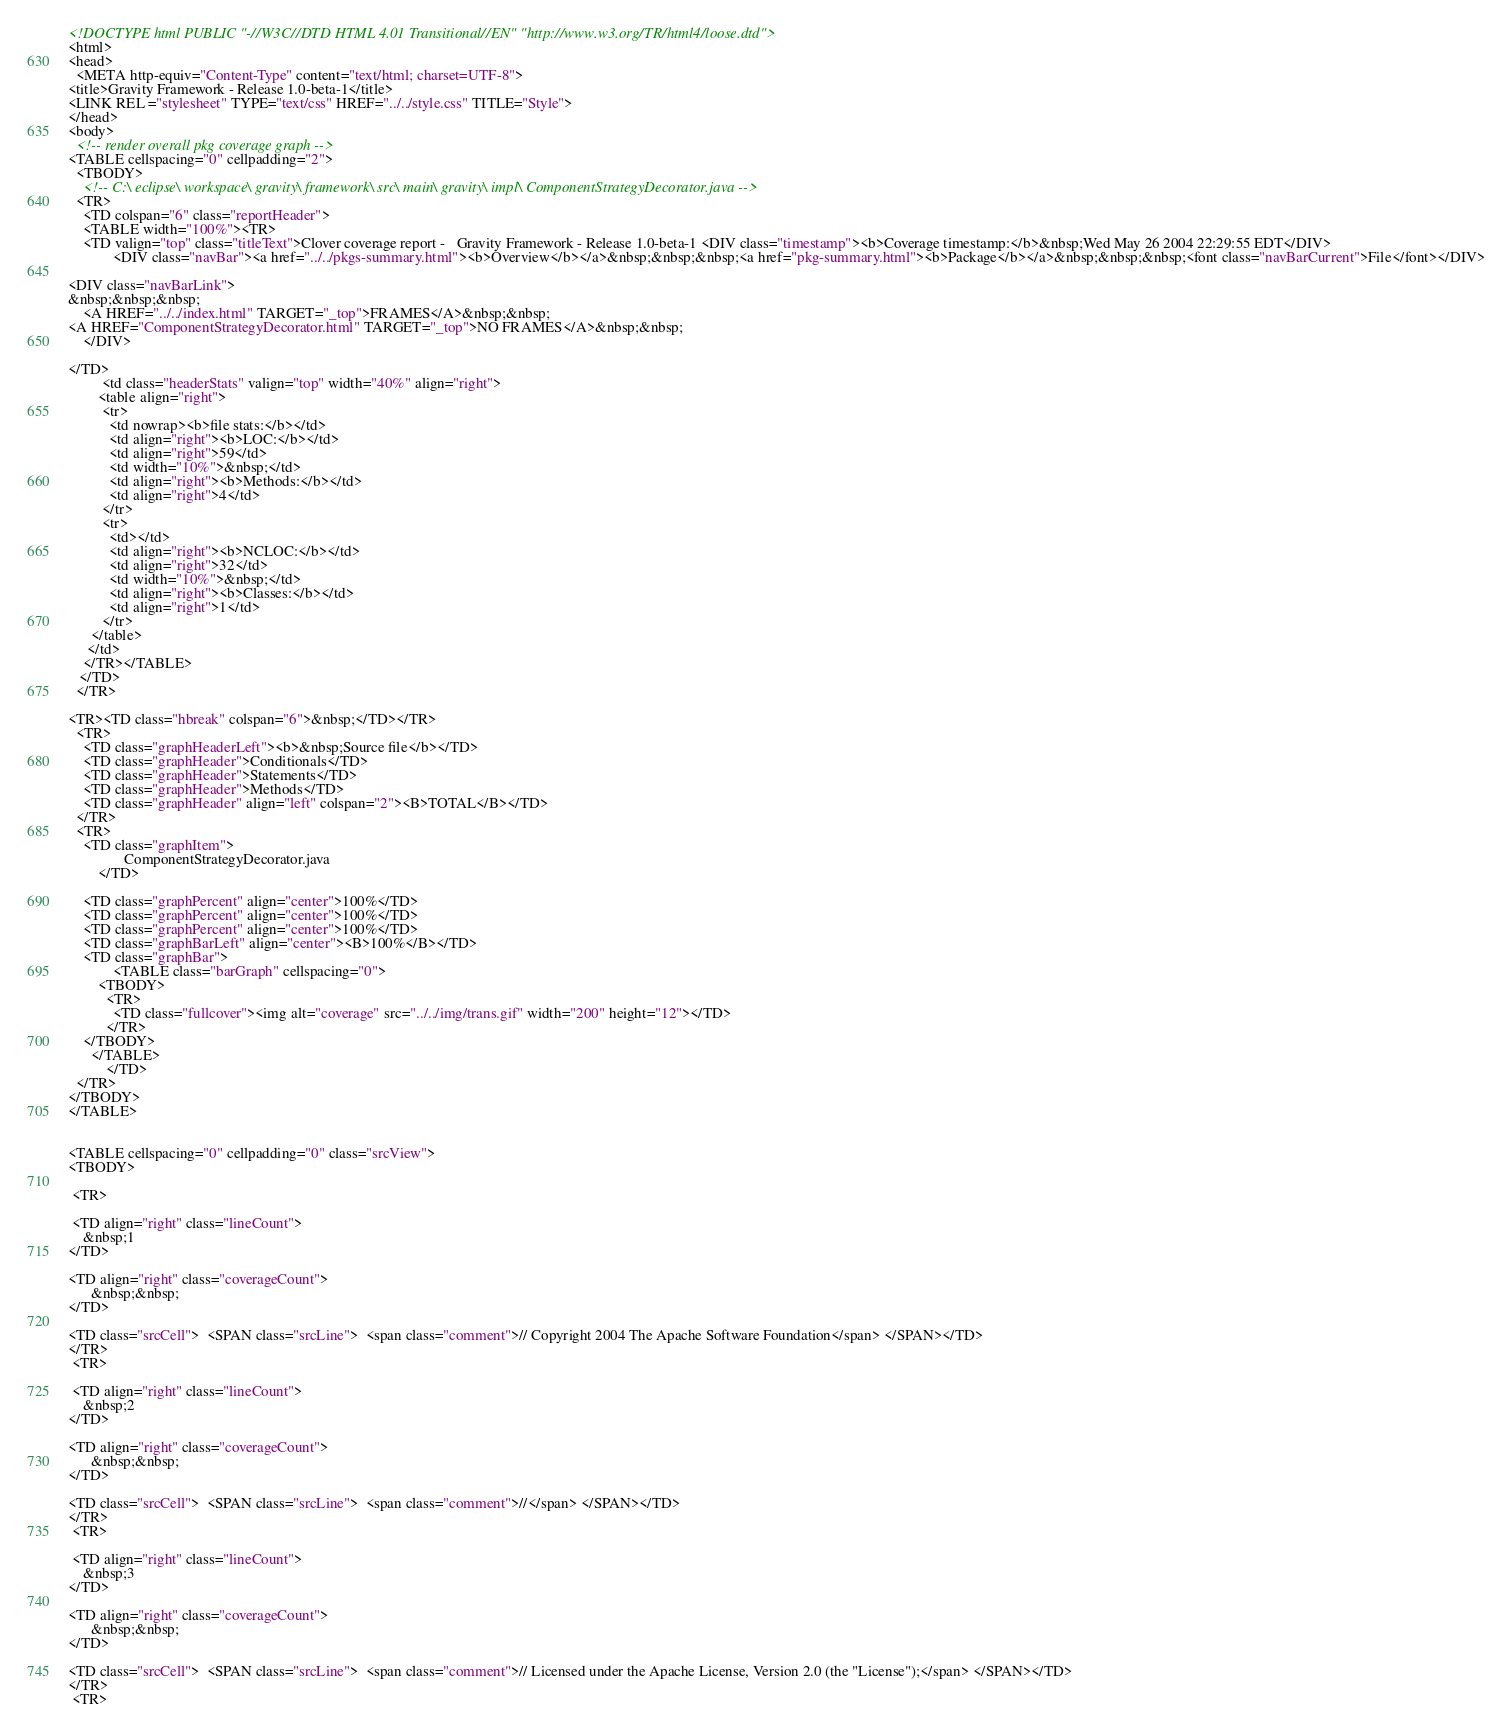Convert code to text. <code><loc_0><loc_0><loc_500><loc_500><_HTML_><!DOCTYPE html PUBLIC "-//W3C//DTD HTML 4.01 Transitional//EN" "http://www.w3.org/TR/html4/loose.dtd">
<html>
<head>
  <META http-equiv="Content-Type" content="text/html; charset=UTF-8">
<title>Gravity Framework - Release 1.0-beta-1</title>
<LINK REL ="stylesheet" TYPE="text/css" HREF="../../style.css" TITLE="Style">
</head>
<body>
  <!-- render overall pkg coverage graph -->
<TABLE cellspacing="0" cellpadding="2">
  <TBODY>
    <!-- C:\ eclipse\ workspace\ gravity\ framework\ src\ main\ gravity\ impl\ ComponentStrategyDecorator.java -->
  <TR>
    <TD colspan="6" class="reportHeader">
    <TABLE width="100%"><TR>
    <TD valign="top" class="titleText">Clover coverage report -   Gravity Framework - Release 1.0-beta-1 <DIV class="timestamp"><b>Coverage timestamp:</b>&nbsp;Wed May 26 2004 22:29:55 EDT</DIV>
            <DIV class="navBar"><a href="../../pkgs-summary.html"><b>Overview</b></a>&nbsp;&nbsp;&nbsp;<a href="pkg-summary.html"><b>Package</b></a>&nbsp;&nbsp;&nbsp;<font class="navBarCurrent">File</font></DIV>
    
<DIV class="navBarLink">
&nbsp;&nbsp;&nbsp;
    <A HREF="../../index.html" TARGET="_top">FRAMES</A>&nbsp;&nbsp;
<A HREF="ComponentStrategyDecorator.html" TARGET="_top">NO FRAMES</A>&nbsp;&nbsp;
    </DIV>

</TD>
         <td class="headerStats" valign="top" width="40%" align="right">
        <table align="right">
         <tr>
           <td nowrap><b>file stats:</b></td>
           <td align="right"><b>LOC:</b></td>
           <td align="right">59</td>
           <td width="10%">&nbsp;</td>
           <td align="right"><b>Methods:</b></td>
           <td align="right">4</td>
         </tr>
         <tr>
           <td></td>
           <td align="right"><b>NCLOC:</b></td>
           <td align="right">32</td>
           <td width="10%">&nbsp;</td>
           <td align="right"><b>Classes:</b></td>
           <td align="right">1</td>
         </tr>
      </table>
     </td>
    </TR></TABLE>
   </TD>
  </TR>

<TR><TD class="hbreak" colspan="6">&nbsp;</TD></TR>
  <TR>
    <TD class="graphHeaderLeft"><b>&nbsp;Source file</b></TD>
    <TD class="graphHeader">Conditionals</TD>
    <TD class="graphHeader">Statements</TD>
    <TD class="graphHeader">Methods</TD>
    <TD class="graphHeader" align="left" colspan="2"><B>TOTAL</B></TD>
  </TR>   
  <TR>
    <TD class="graphItem">
        	   ComponentStrategyDecorator.java
	    </TD>
   
    <TD class="graphPercent" align="center">100%</TD>
    <TD class="graphPercent" align="center">100%</TD>
    <TD class="graphPercent" align="center">100%</TD>
    <TD class="graphBarLeft" align="center"><B>100%</B></TD>
    <TD class="graphBar">
            <TABLE class="barGraph" cellspacing="0">
        <TBODY>
          <TR>
	   	    <TD class="fullcover"><img alt="coverage" src="../../img/trans.gif" width="200" height="12"></TD> 
	   	  </TR>
	</TBODY>
      </TABLE>
          </TD>
  </TR> 
</TBODY>
</TABLE>


<TABLE cellspacing="0" cellpadding="0" class="srcView">
<TBODY>

 <TR>

 <TD align="right" class="lineCount">
    &nbsp;1
</TD>

<TD align="right" class="coverageCount">
      &nbsp;&nbsp;
</TD>

<TD class="srcCell">  <SPAN class="srcLine">  <span class="comment">// Copyright 2004 The Apache Software Foundation</span> </SPAN></TD>
</TR>
 <TR>

 <TD align="right" class="lineCount">
    &nbsp;2
</TD>

<TD align="right" class="coverageCount">
      &nbsp;&nbsp;
</TD>

<TD class="srcCell">  <SPAN class="srcLine">  <span class="comment">//</span> </SPAN></TD>
</TR>
 <TR>

 <TD align="right" class="lineCount">
    &nbsp;3
</TD>

<TD align="right" class="coverageCount">
      &nbsp;&nbsp;
</TD>

<TD class="srcCell">  <SPAN class="srcLine">  <span class="comment">// Licensed under the Apache License, Version 2.0 (the "License");</span> </SPAN></TD>
</TR>
 <TR>
</code> 